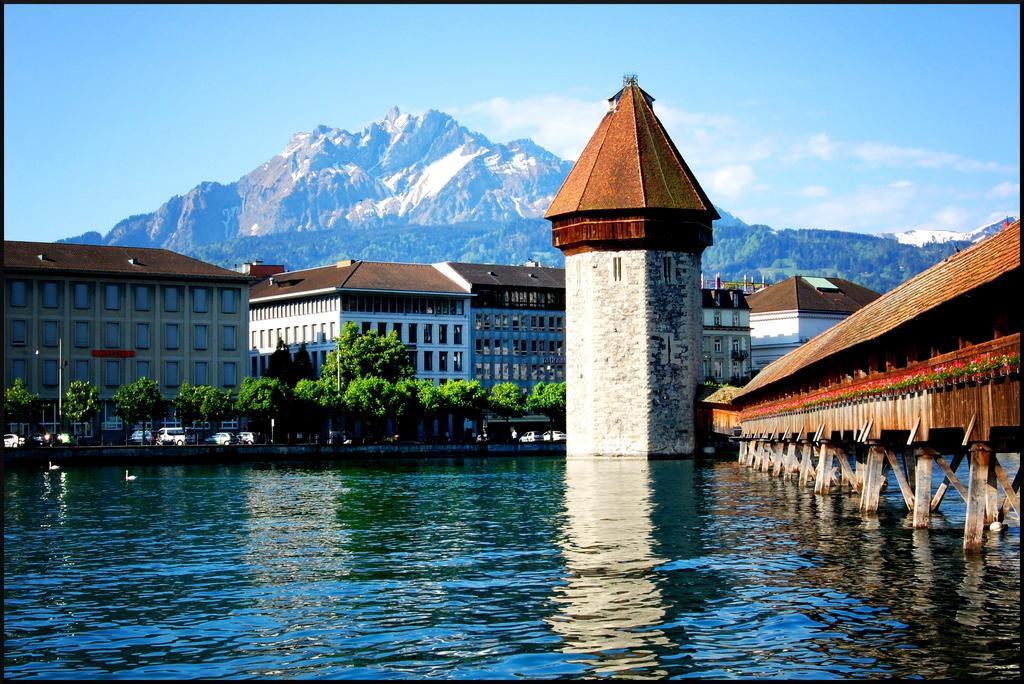What body of water is present in the image? There is a lake in the image. What structure can be seen in the lake? There is a bridge in the lake. What type of vegetation is around the lake? There are trees around the lake. What type of pathway is around the lake? There is a road around the lake. What type of buildings can be seen in the background of the image? There are houses in the background of the image. What geographical feature is visible in the background of the image? There is a mountain in the background of the image. What part of the natural environment is visible in the background of the image? The sky is visible in the background of the image. What type of railway can be seen running through the lake in the image? There is no railway present in the image; it features a lake with a bridge and surrounding landscape. 